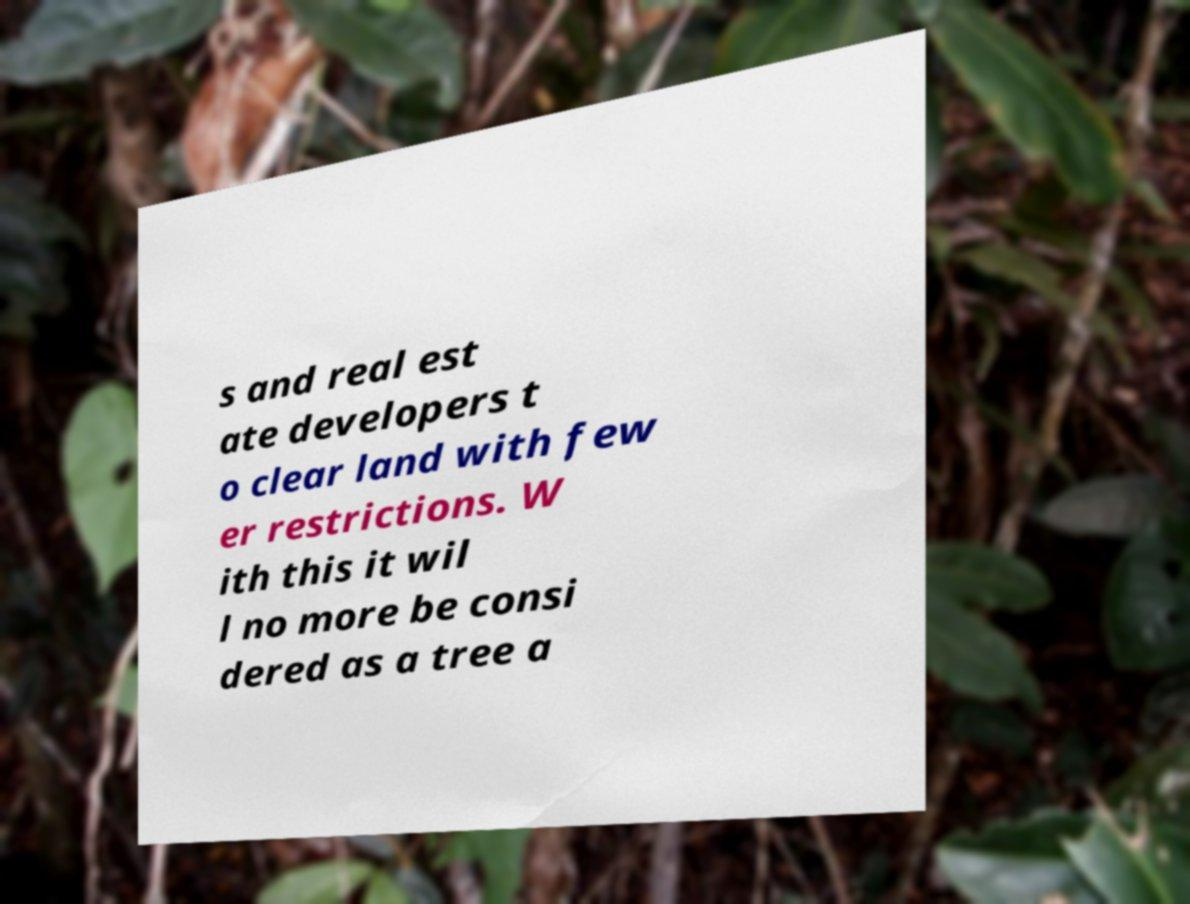Could you extract and type out the text from this image? s and real est ate developers t o clear land with few er restrictions. W ith this it wil l no more be consi dered as a tree a 